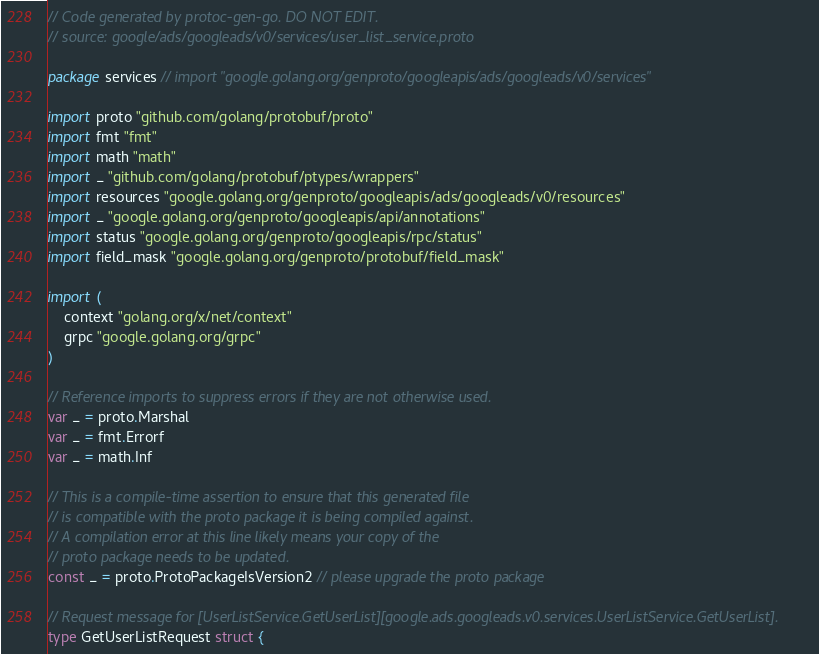Convert code to text. <code><loc_0><loc_0><loc_500><loc_500><_Go_>// Code generated by protoc-gen-go. DO NOT EDIT.
// source: google/ads/googleads/v0/services/user_list_service.proto

package services // import "google.golang.org/genproto/googleapis/ads/googleads/v0/services"

import proto "github.com/golang/protobuf/proto"
import fmt "fmt"
import math "math"
import _ "github.com/golang/protobuf/ptypes/wrappers"
import resources "google.golang.org/genproto/googleapis/ads/googleads/v0/resources"
import _ "google.golang.org/genproto/googleapis/api/annotations"
import status "google.golang.org/genproto/googleapis/rpc/status"
import field_mask "google.golang.org/genproto/protobuf/field_mask"

import (
	context "golang.org/x/net/context"
	grpc "google.golang.org/grpc"
)

// Reference imports to suppress errors if they are not otherwise used.
var _ = proto.Marshal
var _ = fmt.Errorf
var _ = math.Inf

// This is a compile-time assertion to ensure that this generated file
// is compatible with the proto package it is being compiled against.
// A compilation error at this line likely means your copy of the
// proto package needs to be updated.
const _ = proto.ProtoPackageIsVersion2 // please upgrade the proto package

// Request message for [UserListService.GetUserList][google.ads.googleads.v0.services.UserListService.GetUserList].
type GetUserListRequest struct {</code> 